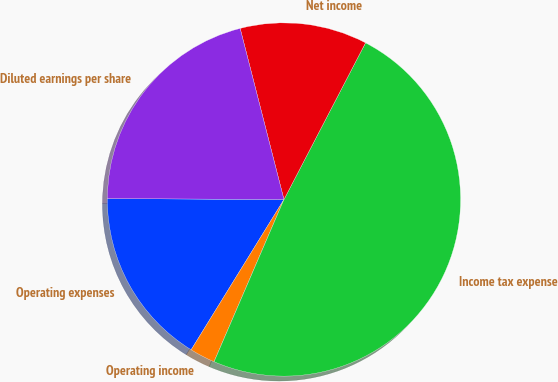Convert chart. <chart><loc_0><loc_0><loc_500><loc_500><pie_chart><fcel>Operating expenses<fcel>Operating income<fcel>Income tax expense<fcel>Net income<fcel>Diluted earnings per share<nl><fcel>16.28%<fcel>2.33%<fcel>48.84%<fcel>11.63%<fcel>20.93%<nl></chart> 